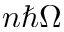Convert formula to latex. <formula><loc_0><loc_0><loc_500><loc_500>n \hbar { \Omega }</formula> 